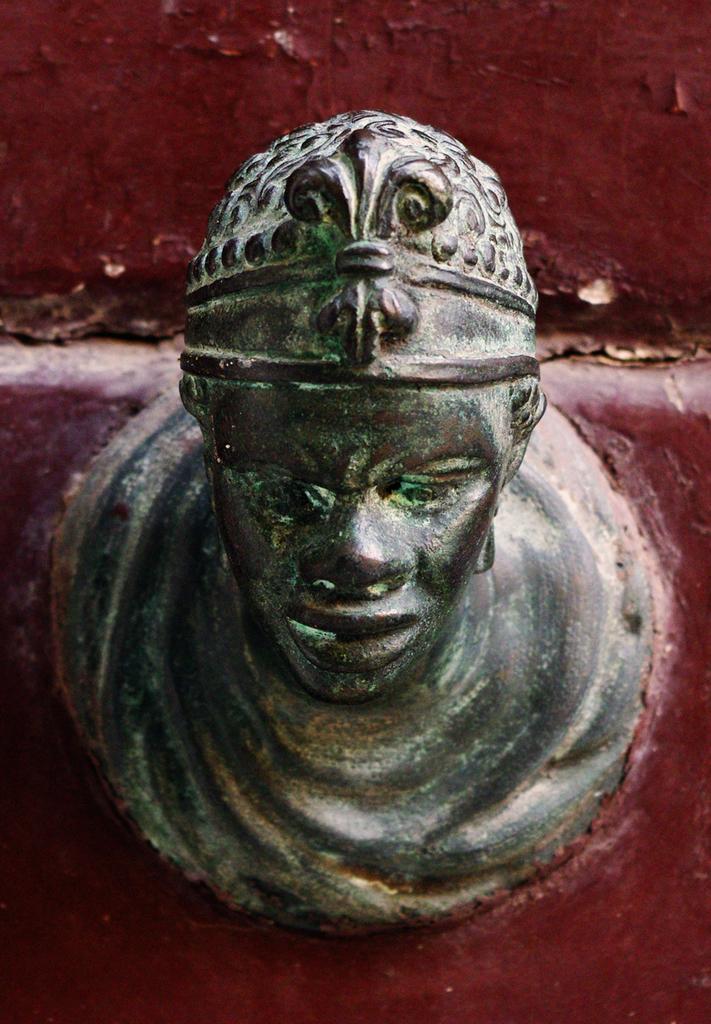Could you give a brief overview of what you see in this image? In this picture I can observe sculpture in the middle of the picture. In the background I can observe maroon color wall. 